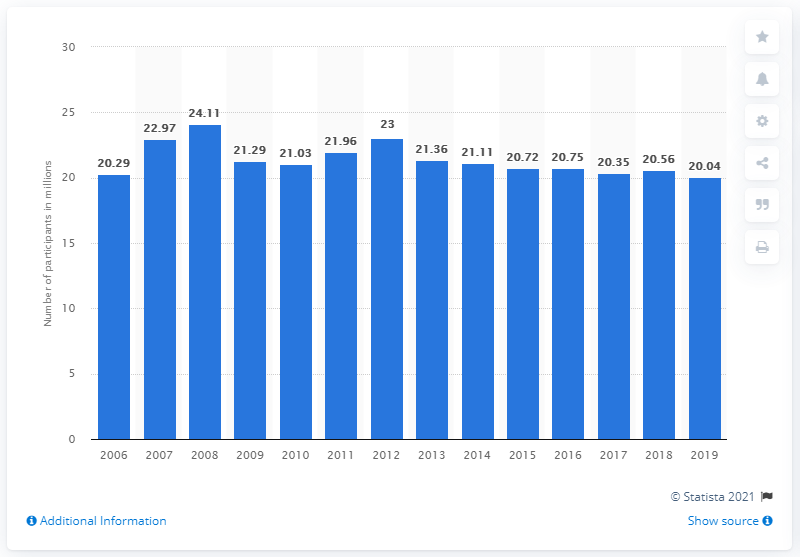Give some essential details in this illustration. The number of participants in wildlife viewing in the United States from 2006 to 2019 was 20.56 million. In 2019, approximately 20.04 million people participated in wildlife viewing in the United States. 